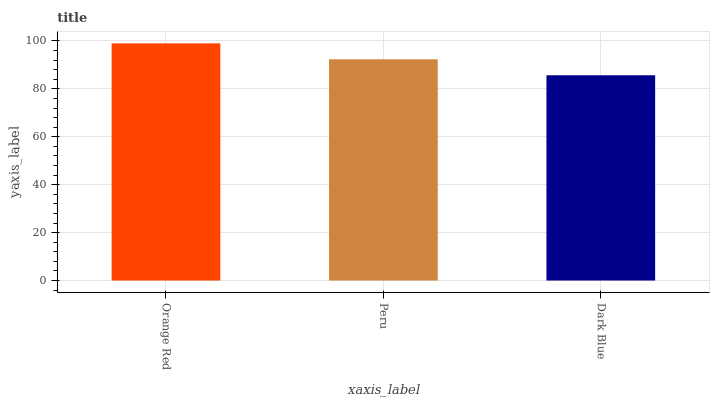Is Peru the minimum?
Answer yes or no. No. Is Peru the maximum?
Answer yes or no. No. Is Orange Red greater than Peru?
Answer yes or no. Yes. Is Peru less than Orange Red?
Answer yes or no. Yes. Is Peru greater than Orange Red?
Answer yes or no. No. Is Orange Red less than Peru?
Answer yes or no. No. Is Peru the high median?
Answer yes or no. Yes. Is Peru the low median?
Answer yes or no. Yes. Is Dark Blue the high median?
Answer yes or no. No. Is Orange Red the low median?
Answer yes or no. No. 